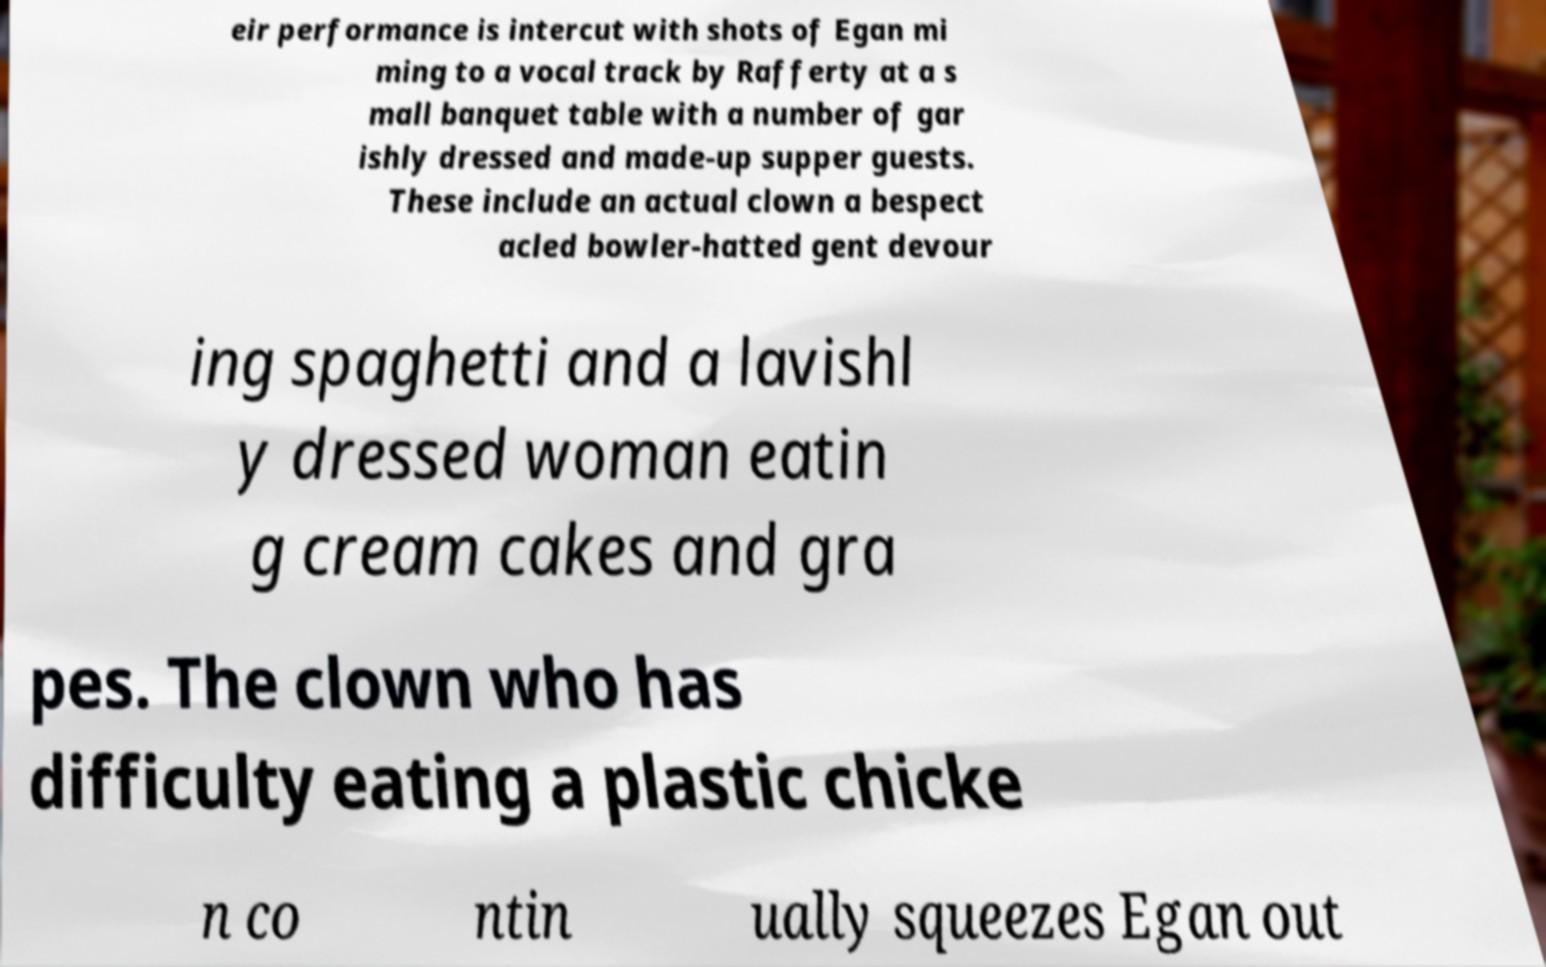Could you extract and type out the text from this image? eir performance is intercut with shots of Egan mi ming to a vocal track by Rafferty at a s mall banquet table with a number of gar ishly dressed and made-up supper guests. These include an actual clown a bespect acled bowler-hatted gent devour ing spaghetti and a lavishl y dressed woman eatin g cream cakes and gra pes. The clown who has difficulty eating a plastic chicke n co ntin ually squeezes Egan out 